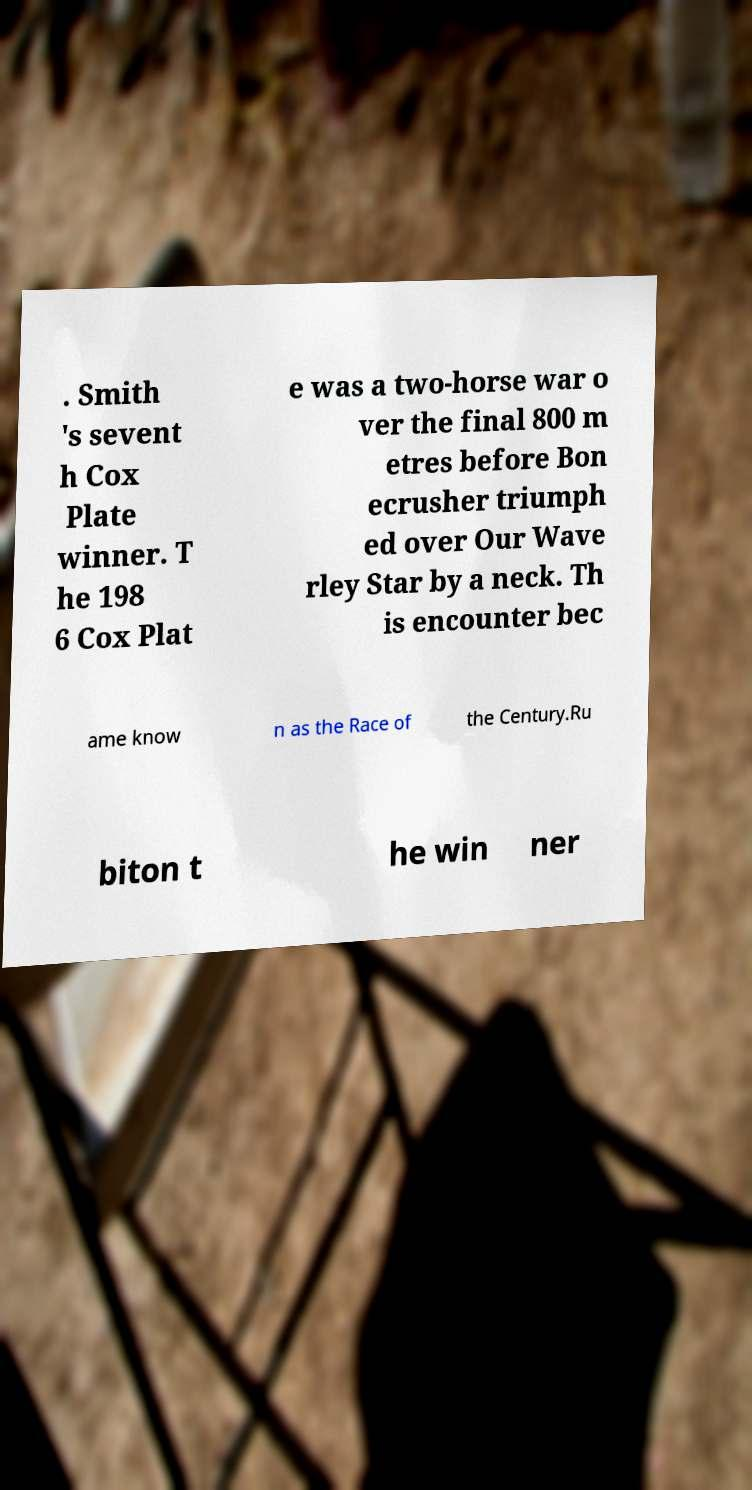I need the written content from this picture converted into text. Can you do that? . Smith 's sevent h Cox Plate winner. T he 198 6 Cox Plat e was a two-horse war o ver the final 800 m etres before Bon ecrusher triumph ed over Our Wave rley Star by a neck. Th is encounter bec ame know n as the Race of the Century.Ru biton t he win ner 